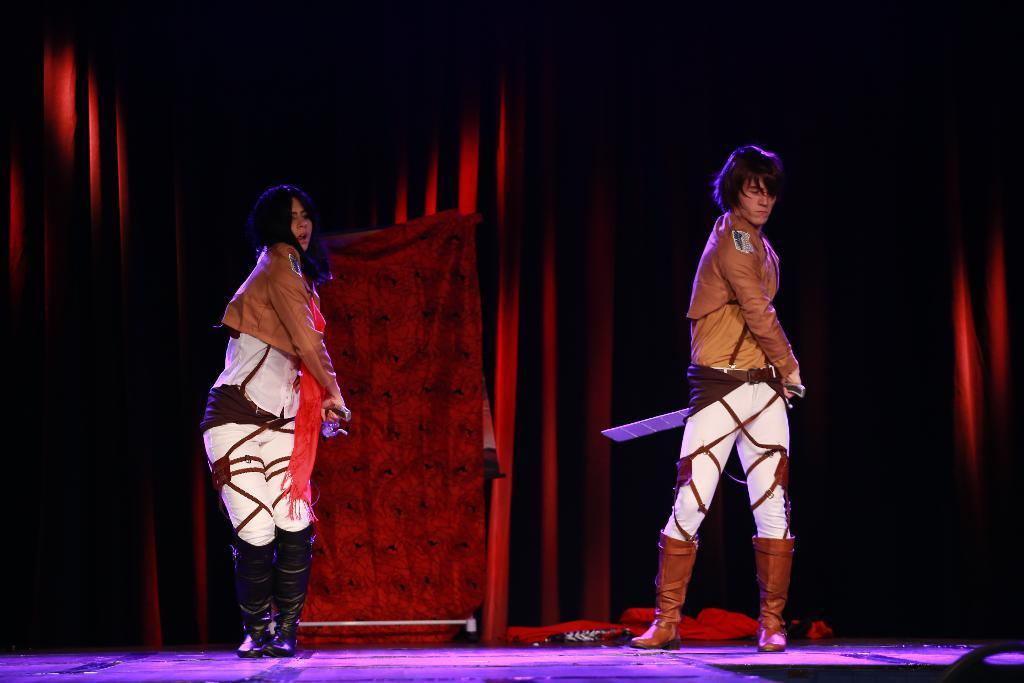Who are the people in the image? There is a man and a woman in the image. What are the man and woman doing in the image? Both the man and woman are performing on a dais. What can be seen in the background of the image? There are curtains in the background of the image. What type of van can be seen parked near the dais in the image? There is no van present in the image; it only features the man, woman, and curtains in the background. 